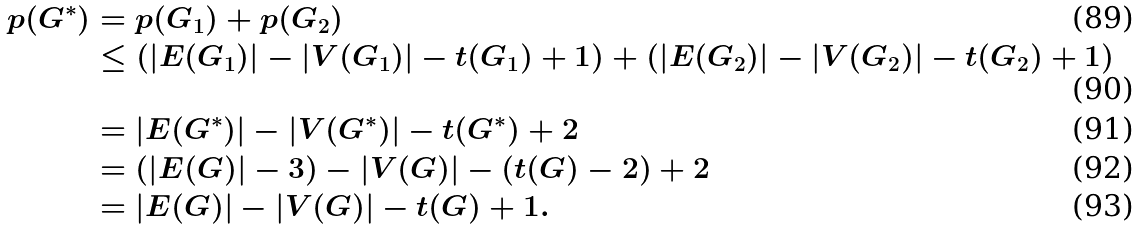<formula> <loc_0><loc_0><loc_500><loc_500>p ( G ^ { * } ) & = p ( G _ { 1 } ) + p ( G _ { 2 } ) \\ & \leq ( | E ( G _ { 1 } ) | - | V ( G _ { 1 } ) | - t ( G _ { 1 } ) + 1 ) + ( | E ( G _ { 2 } ) | - | V ( G _ { 2 } ) | - t ( G _ { 2 } ) + 1 ) \\ & = | E ( G ^ { * } ) | - | V ( G ^ { * } ) | - t ( G ^ { * } ) + 2 \\ & = ( | E ( G ) | - 3 ) - | V ( G ) | - ( t ( G ) - 2 ) + 2 \\ & = | E ( G ) | - | V ( G ) | - t ( G ) + 1 .</formula> 